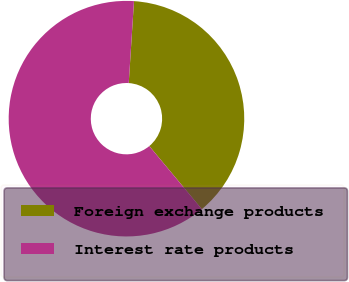<chart> <loc_0><loc_0><loc_500><loc_500><pie_chart><fcel>Foreign exchange products<fcel>Interest rate products<nl><fcel>37.93%<fcel>62.07%<nl></chart> 